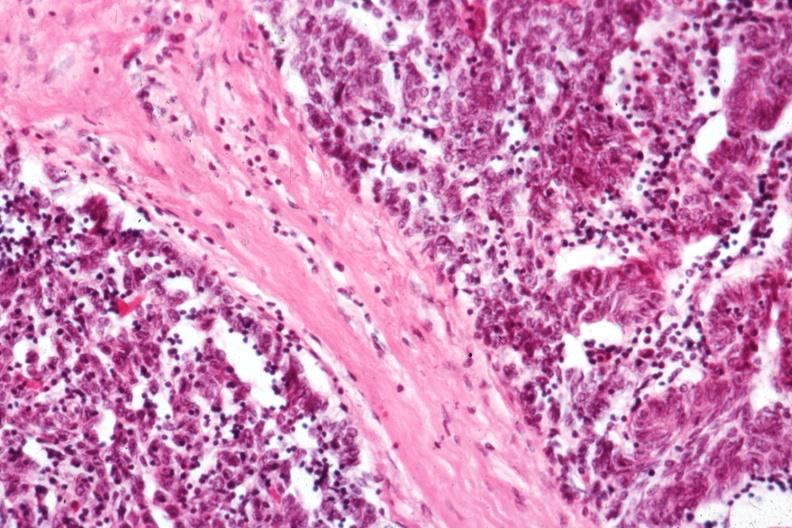s omphalocele present?
Answer the question using a single word or phrase. No 